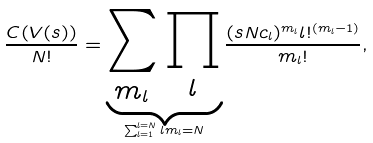Convert formula to latex. <formula><loc_0><loc_0><loc_500><loc_500>\frac { C ( V ( s ) ) } { N ! } = \underbrace { \sum _ { m _ { l } } \prod _ { l } } _ { \sum _ { l = 1 } ^ { l = N } l m _ { l } = N } \frac { ( { s } N c _ { l } ) ^ { m _ { l } } l ! ^ { ( m _ { l } - 1 ) } } { m _ { l } ! } ,</formula> 